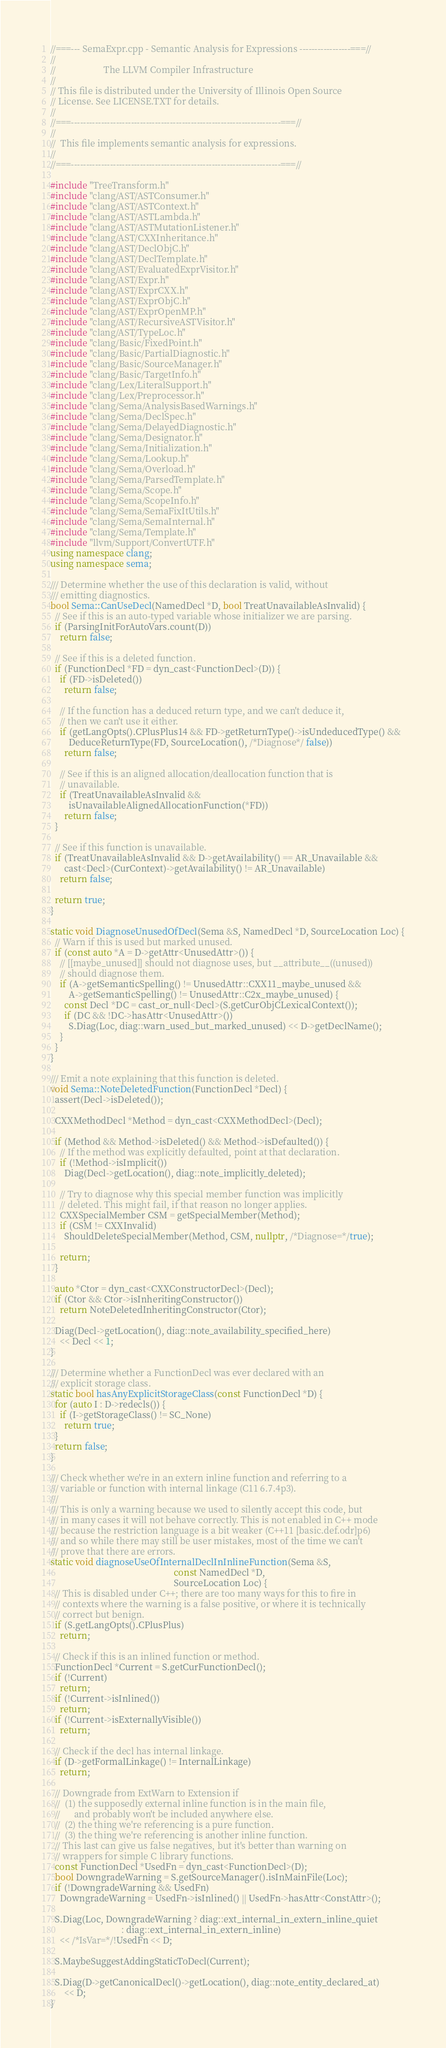<code> <loc_0><loc_0><loc_500><loc_500><_C++_>//===--- SemaExpr.cpp - Semantic Analysis for Expressions -----------------===//
//
//                     The LLVM Compiler Infrastructure
//
// This file is distributed under the University of Illinois Open Source
// License. See LICENSE.TXT for details.
//
//===----------------------------------------------------------------------===//
//
//  This file implements semantic analysis for expressions.
//
//===----------------------------------------------------------------------===//

#include "TreeTransform.h"
#include "clang/AST/ASTConsumer.h"
#include "clang/AST/ASTContext.h"
#include "clang/AST/ASTLambda.h"
#include "clang/AST/ASTMutationListener.h"
#include "clang/AST/CXXInheritance.h"
#include "clang/AST/DeclObjC.h"
#include "clang/AST/DeclTemplate.h"
#include "clang/AST/EvaluatedExprVisitor.h"
#include "clang/AST/Expr.h"
#include "clang/AST/ExprCXX.h"
#include "clang/AST/ExprObjC.h"
#include "clang/AST/ExprOpenMP.h"
#include "clang/AST/RecursiveASTVisitor.h"
#include "clang/AST/TypeLoc.h"
#include "clang/Basic/FixedPoint.h"
#include "clang/Basic/PartialDiagnostic.h"
#include "clang/Basic/SourceManager.h"
#include "clang/Basic/TargetInfo.h"
#include "clang/Lex/LiteralSupport.h"
#include "clang/Lex/Preprocessor.h"
#include "clang/Sema/AnalysisBasedWarnings.h"
#include "clang/Sema/DeclSpec.h"
#include "clang/Sema/DelayedDiagnostic.h"
#include "clang/Sema/Designator.h"
#include "clang/Sema/Initialization.h"
#include "clang/Sema/Lookup.h"
#include "clang/Sema/Overload.h"
#include "clang/Sema/ParsedTemplate.h"
#include "clang/Sema/Scope.h"
#include "clang/Sema/ScopeInfo.h"
#include "clang/Sema/SemaFixItUtils.h"
#include "clang/Sema/SemaInternal.h"
#include "clang/Sema/Template.h"
#include "llvm/Support/ConvertUTF.h"
using namespace clang;
using namespace sema;

/// Determine whether the use of this declaration is valid, without
/// emitting diagnostics.
bool Sema::CanUseDecl(NamedDecl *D, bool TreatUnavailableAsInvalid) {
  // See if this is an auto-typed variable whose initializer we are parsing.
  if (ParsingInitForAutoVars.count(D))
    return false;

  // See if this is a deleted function.
  if (FunctionDecl *FD = dyn_cast<FunctionDecl>(D)) {
    if (FD->isDeleted())
      return false;

    // If the function has a deduced return type, and we can't deduce it,
    // then we can't use it either.
    if (getLangOpts().CPlusPlus14 && FD->getReturnType()->isUndeducedType() &&
        DeduceReturnType(FD, SourceLocation(), /*Diagnose*/ false))
      return false;

    // See if this is an aligned allocation/deallocation function that is
    // unavailable.
    if (TreatUnavailableAsInvalid &&
        isUnavailableAlignedAllocationFunction(*FD))
      return false;
  }

  // See if this function is unavailable.
  if (TreatUnavailableAsInvalid && D->getAvailability() == AR_Unavailable &&
      cast<Decl>(CurContext)->getAvailability() != AR_Unavailable)
    return false;

  return true;
}

static void DiagnoseUnusedOfDecl(Sema &S, NamedDecl *D, SourceLocation Loc) {
  // Warn if this is used but marked unused.
  if (const auto *A = D->getAttr<UnusedAttr>()) {
    // [[maybe_unused]] should not diagnose uses, but __attribute__((unused))
    // should diagnose them.
    if (A->getSemanticSpelling() != UnusedAttr::CXX11_maybe_unused &&
        A->getSemanticSpelling() != UnusedAttr::C2x_maybe_unused) {
      const Decl *DC = cast_or_null<Decl>(S.getCurObjCLexicalContext());
      if (DC && !DC->hasAttr<UnusedAttr>())
        S.Diag(Loc, diag::warn_used_but_marked_unused) << D->getDeclName();
    }
  }
}

/// Emit a note explaining that this function is deleted.
void Sema::NoteDeletedFunction(FunctionDecl *Decl) {
  assert(Decl->isDeleted());

  CXXMethodDecl *Method = dyn_cast<CXXMethodDecl>(Decl);

  if (Method && Method->isDeleted() && Method->isDefaulted()) {
    // If the method was explicitly defaulted, point at that declaration.
    if (!Method->isImplicit())
      Diag(Decl->getLocation(), diag::note_implicitly_deleted);

    // Try to diagnose why this special member function was implicitly
    // deleted. This might fail, if that reason no longer applies.
    CXXSpecialMember CSM = getSpecialMember(Method);
    if (CSM != CXXInvalid)
      ShouldDeleteSpecialMember(Method, CSM, nullptr, /*Diagnose=*/true);

    return;
  }

  auto *Ctor = dyn_cast<CXXConstructorDecl>(Decl);
  if (Ctor && Ctor->isInheritingConstructor())
    return NoteDeletedInheritingConstructor(Ctor);

  Diag(Decl->getLocation(), diag::note_availability_specified_here)
    << Decl << 1;
}

/// Determine whether a FunctionDecl was ever declared with an
/// explicit storage class.
static bool hasAnyExplicitStorageClass(const FunctionDecl *D) {
  for (auto I : D->redecls()) {
    if (I->getStorageClass() != SC_None)
      return true;
  }
  return false;
}

/// Check whether we're in an extern inline function and referring to a
/// variable or function with internal linkage (C11 6.7.4p3).
///
/// This is only a warning because we used to silently accept this code, but
/// in many cases it will not behave correctly. This is not enabled in C++ mode
/// because the restriction language is a bit weaker (C++11 [basic.def.odr]p6)
/// and so while there may still be user mistakes, most of the time we can't
/// prove that there are errors.
static void diagnoseUseOfInternalDeclInInlineFunction(Sema &S,
                                                      const NamedDecl *D,
                                                      SourceLocation Loc) {
  // This is disabled under C++; there are too many ways for this to fire in
  // contexts where the warning is a false positive, or where it is technically
  // correct but benign.
  if (S.getLangOpts().CPlusPlus)
    return;

  // Check if this is an inlined function or method.
  FunctionDecl *Current = S.getCurFunctionDecl();
  if (!Current)
    return;
  if (!Current->isInlined())
    return;
  if (!Current->isExternallyVisible())
    return;

  // Check if the decl has internal linkage.
  if (D->getFormalLinkage() != InternalLinkage)
    return;

  // Downgrade from ExtWarn to Extension if
  //  (1) the supposedly external inline function is in the main file,
  //      and probably won't be included anywhere else.
  //  (2) the thing we're referencing is a pure function.
  //  (3) the thing we're referencing is another inline function.
  // This last can give us false negatives, but it's better than warning on
  // wrappers for simple C library functions.
  const FunctionDecl *UsedFn = dyn_cast<FunctionDecl>(D);
  bool DowngradeWarning = S.getSourceManager().isInMainFile(Loc);
  if (!DowngradeWarning && UsedFn)
    DowngradeWarning = UsedFn->isInlined() || UsedFn->hasAttr<ConstAttr>();

  S.Diag(Loc, DowngradeWarning ? diag::ext_internal_in_extern_inline_quiet
                               : diag::ext_internal_in_extern_inline)
    << /*IsVar=*/!UsedFn << D;

  S.MaybeSuggestAddingStaticToDecl(Current);

  S.Diag(D->getCanonicalDecl()->getLocation(), diag::note_entity_declared_at)
      << D;
}
</code> 